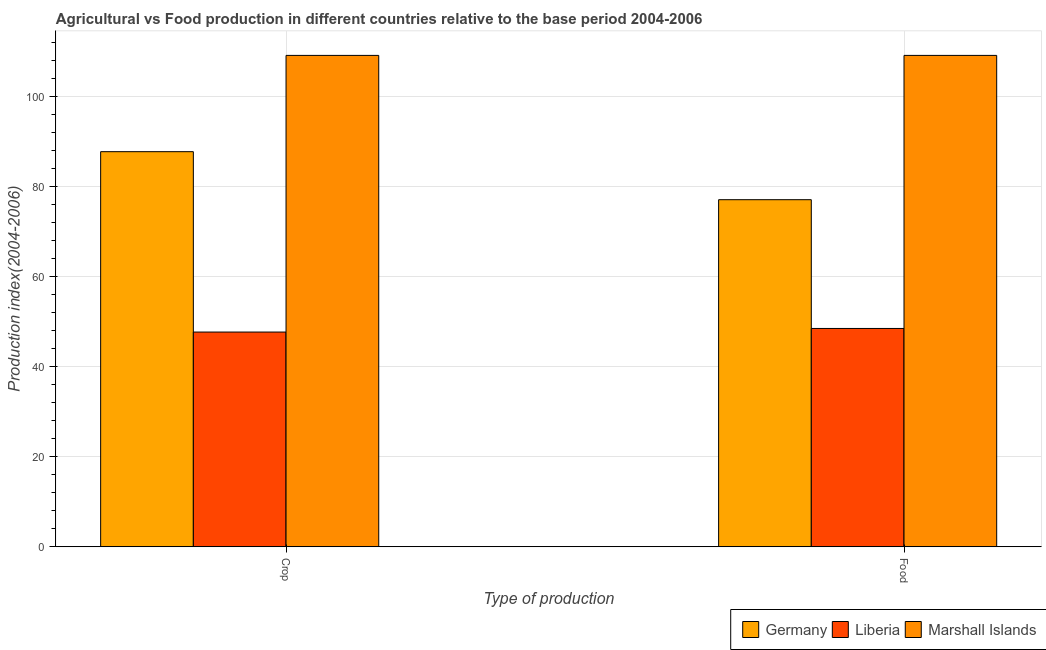How many different coloured bars are there?
Keep it short and to the point. 3. How many groups of bars are there?
Ensure brevity in your answer.  2. Are the number of bars on each tick of the X-axis equal?
Your response must be concise. Yes. What is the label of the 1st group of bars from the left?
Provide a succinct answer. Crop. What is the food production index in Liberia?
Offer a terse response. 48.47. Across all countries, what is the maximum food production index?
Provide a succinct answer. 109.1. Across all countries, what is the minimum crop production index?
Provide a short and direct response. 47.67. In which country was the food production index maximum?
Offer a very short reply. Marshall Islands. In which country was the food production index minimum?
Give a very brief answer. Liberia. What is the total food production index in the graph?
Ensure brevity in your answer.  234.63. What is the difference between the food production index in Liberia and that in Germany?
Provide a short and direct response. -28.59. What is the difference between the food production index in Marshall Islands and the crop production index in Liberia?
Give a very brief answer. 61.43. What is the average food production index per country?
Give a very brief answer. 78.21. What is the difference between the crop production index and food production index in Liberia?
Give a very brief answer. -0.8. What is the ratio of the crop production index in Liberia to that in Marshall Islands?
Provide a short and direct response. 0.44. What does the 3rd bar from the left in Crop represents?
Your answer should be very brief. Marshall Islands. How many bars are there?
Your response must be concise. 6. How many countries are there in the graph?
Keep it short and to the point. 3. Are the values on the major ticks of Y-axis written in scientific E-notation?
Your response must be concise. No. Does the graph contain grids?
Give a very brief answer. Yes. Where does the legend appear in the graph?
Provide a short and direct response. Bottom right. How many legend labels are there?
Your answer should be very brief. 3. How are the legend labels stacked?
Make the answer very short. Horizontal. What is the title of the graph?
Give a very brief answer. Agricultural vs Food production in different countries relative to the base period 2004-2006. What is the label or title of the X-axis?
Give a very brief answer. Type of production. What is the label or title of the Y-axis?
Your answer should be compact. Production index(2004-2006). What is the Production index(2004-2006) in Germany in Crop?
Your answer should be compact. 87.72. What is the Production index(2004-2006) in Liberia in Crop?
Provide a succinct answer. 47.67. What is the Production index(2004-2006) in Marshall Islands in Crop?
Provide a short and direct response. 109.1. What is the Production index(2004-2006) of Germany in Food?
Ensure brevity in your answer.  77.06. What is the Production index(2004-2006) in Liberia in Food?
Offer a very short reply. 48.47. What is the Production index(2004-2006) in Marshall Islands in Food?
Keep it short and to the point. 109.1. Across all Type of production, what is the maximum Production index(2004-2006) of Germany?
Give a very brief answer. 87.72. Across all Type of production, what is the maximum Production index(2004-2006) in Liberia?
Your answer should be very brief. 48.47. Across all Type of production, what is the maximum Production index(2004-2006) in Marshall Islands?
Provide a succinct answer. 109.1. Across all Type of production, what is the minimum Production index(2004-2006) of Germany?
Make the answer very short. 77.06. Across all Type of production, what is the minimum Production index(2004-2006) in Liberia?
Your answer should be compact. 47.67. Across all Type of production, what is the minimum Production index(2004-2006) in Marshall Islands?
Make the answer very short. 109.1. What is the total Production index(2004-2006) in Germany in the graph?
Your response must be concise. 164.78. What is the total Production index(2004-2006) of Liberia in the graph?
Make the answer very short. 96.14. What is the total Production index(2004-2006) in Marshall Islands in the graph?
Keep it short and to the point. 218.2. What is the difference between the Production index(2004-2006) of Germany in Crop and that in Food?
Your response must be concise. 10.66. What is the difference between the Production index(2004-2006) in Marshall Islands in Crop and that in Food?
Offer a very short reply. 0. What is the difference between the Production index(2004-2006) of Germany in Crop and the Production index(2004-2006) of Liberia in Food?
Provide a succinct answer. 39.25. What is the difference between the Production index(2004-2006) of Germany in Crop and the Production index(2004-2006) of Marshall Islands in Food?
Your answer should be very brief. -21.38. What is the difference between the Production index(2004-2006) of Liberia in Crop and the Production index(2004-2006) of Marshall Islands in Food?
Provide a short and direct response. -61.43. What is the average Production index(2004-2006) of Germany per Type of production?
Give a very brief answer. 82.39. What is the average Production index(2004-2006) of Liberia per Type of production?
Your answer should be compact. 48.07. What is the average Production index(2004-2006) of Marshall Islands per Type of production?
Offer a terse response. 109.1. What is the difference between the Production index(2004-2006) in Germany and Production index(2004-2006) in Liberia in Crop?
Keep it short and to the point. 40.05. What is the difference between the Production index(2004-2006) of Germany and Production index(2004-2006) of Marshall Islands in Crop?
Ensure brevity in your answer.  -21.38. What is the difference between the Production index(2004-2006) of Liberia and Production index(2004-2006) of Marshall Islands in Crop?
Offer a terse response. -61.43. What is the difference between the Production index(2004-2006) in Germany and Production index(2004-2006) in Liberia in Food?
Give a very brief answer. 28.59. What is the difference between the Production index(2004-2006) in Germany and Production index(2004-2006) in Marshall Islands in Food?
Provide a short and direct response. -32.04. What is the difference between the Production index(2004-2006) in Liberia and Production index(2004-2006) in Marshall Islands in Food?
Your response must be concise. -60.63. What is the ratio of the Production index(2004-2006) of Germany in Crop to that in Food?
Your answer should be compact. 1.14. What is the ratio of the Production index(2004-2006) of Liberia in Crop to that in Food?
Keep it short and to the point. 0.98. What is the ratio of the Production index(2004-2006) in Marshall Islands in Crop to that in Food?
Give a very brief answer. 1. What is the difference between the highest and the second highest Production index(2004-2006) of Germany?
Provide a succinct answer. 10.66. What is the difference between the highest and the second highest Production index(2004-2006) of Liberia?
Your response must be concise. 0.8. What is the difference between the highest and the second highest Production index(2004-2006) of Marshall Islands?
Your response must be concise. 0. What is the difference between the highest and the lowest Production index(2004-2006) of Germany?
Offer a very short reply. 10.66. What is the difference between the highest and the lowest Production index(2004-2006) in Marshall Islands?
Keep it short and to the point. 0. 